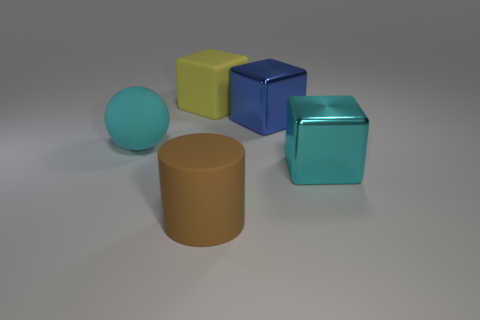Add 4 small brown blocks. How many objects exist? 9 Subtract all blocks. How many objects are left? 2 Add 5 brown matte cylinders. How many brown matte cylinders are left? 6 Add 3 cyan shiny cubes. How many cyan shiny cubes exist? 4 Subtract 0 blue spheres. How many objects are left? 5 Subtract all big cyan balls. Subtract all big yellow blocks. How many objects are left? 3 